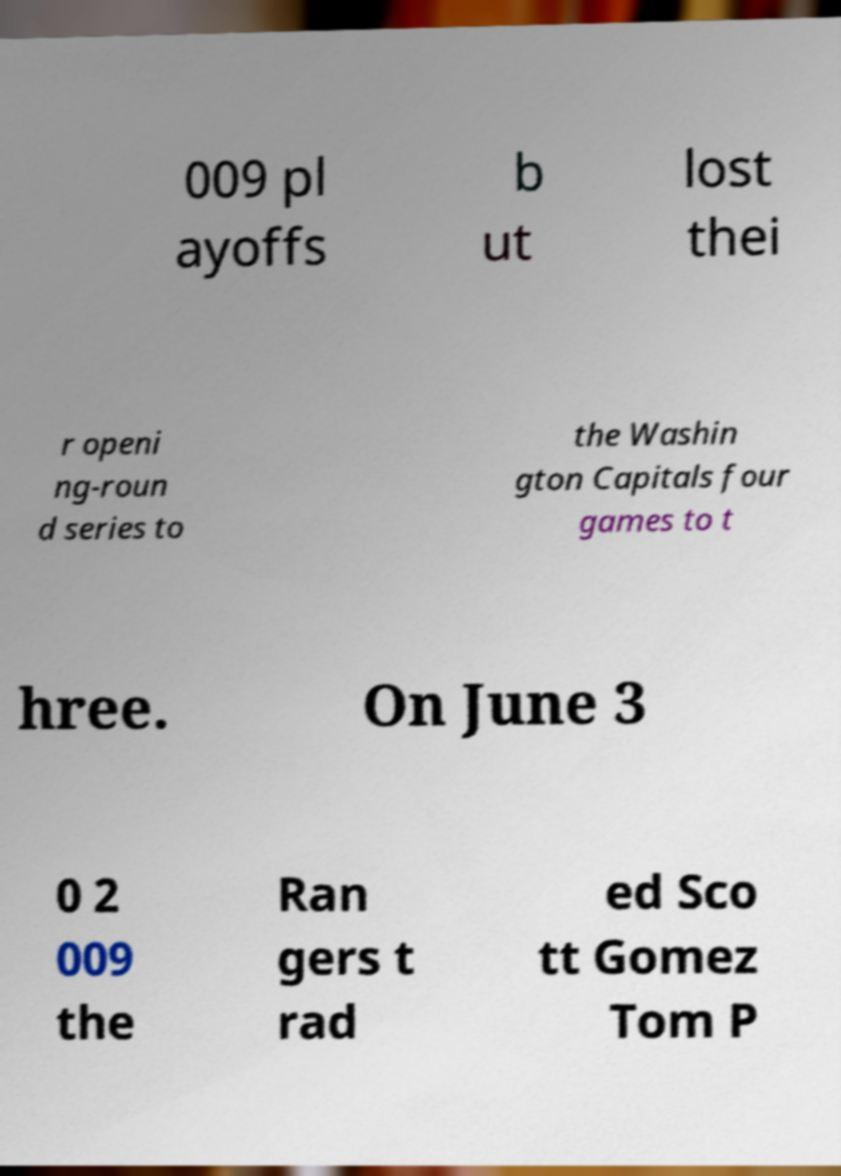There's text embedded in this image that I need extracted. Can you transcribe it verbatim? 009 pl ayoffs b ut lost thei r openi ng-roun d series to the Washin gton Capitals four games to t hree. On June 3 0 2 009 the Ran gers t rad ed Sco tt Gomez Tom P 